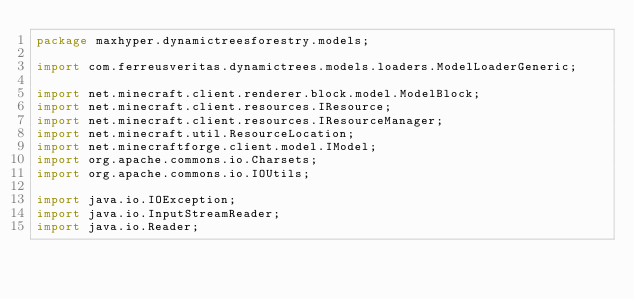<code> <loc_0><loc_0><loc_500><loc_500><_Java_>package maxhyper.dynamictreesforestry.models;

import com.ferreusveritas.dynamictrees.models.loaders.ModelLoaderGeneric;

import net.minecraft.client.renderer.block.model.ModelBlock;
import net.minecraft.client.resources.IResource;
import net.minecraft.client.resources.IResourceManager;
import net.minecraft.util.ResourceLocation;
import net.minecraftforge.client.model.IModel;
import org.apache.commons.io.Charsets;
import org.apache.commons.io.IOUtils;

import java.io.IOException;
import java.io.InputStreamReader;
import java.io.Reader;
</code> 